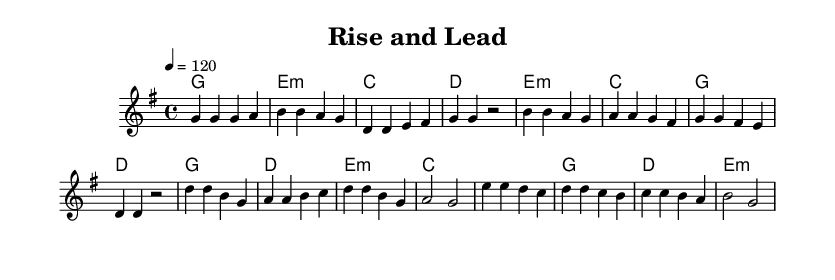What is the key signature of this music? The key signature is G major, which has one sharp (F#). This is indicated at the beginning of the score.
Answer: G major What is the time signature of this piece? The time signature is 4/4, as seen at the beginning of the score. This means there are four beats in a measure, and the quarter note gets one beat.
Answer: 4/4 What is the tempo marking for this piece? The tempo marking is 120 beats per minute, indicated by the tempo written as "4 = 120" at the start.
Answer: 120 How many measures are in the verse section? The verse section consists of 4 measures, which can be counted by observing the division between each set of bar lines in the melody part.
Answer: 4 What is the first chord in the chorus? The first chord in the chorus is D major, identified by the chord symbols written above the staff for the start of that section.
Answer: D How many different sections are there in total? There are four sections overall: Verse, Pre-Chorus, Chorus, and Bridge. Each section is distinct and contributes to the structure of the song.
Answer: 4 What type of music is this piece classified as? This is classified as a Christian pop anthem, emphasizing themes of personal growth and leadership through uplifting lyrics and melodies.
Answer: Christian pop anthem 